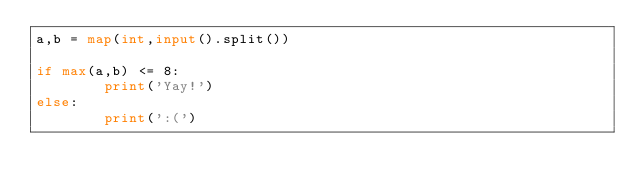<code> <loc_0><loc_0><loc_500><loc_500><_Python_>a,b = map(int,input().split())

if max(a,b) <= 8:
        print('Yay!')
else:
        print(':(')</code> 